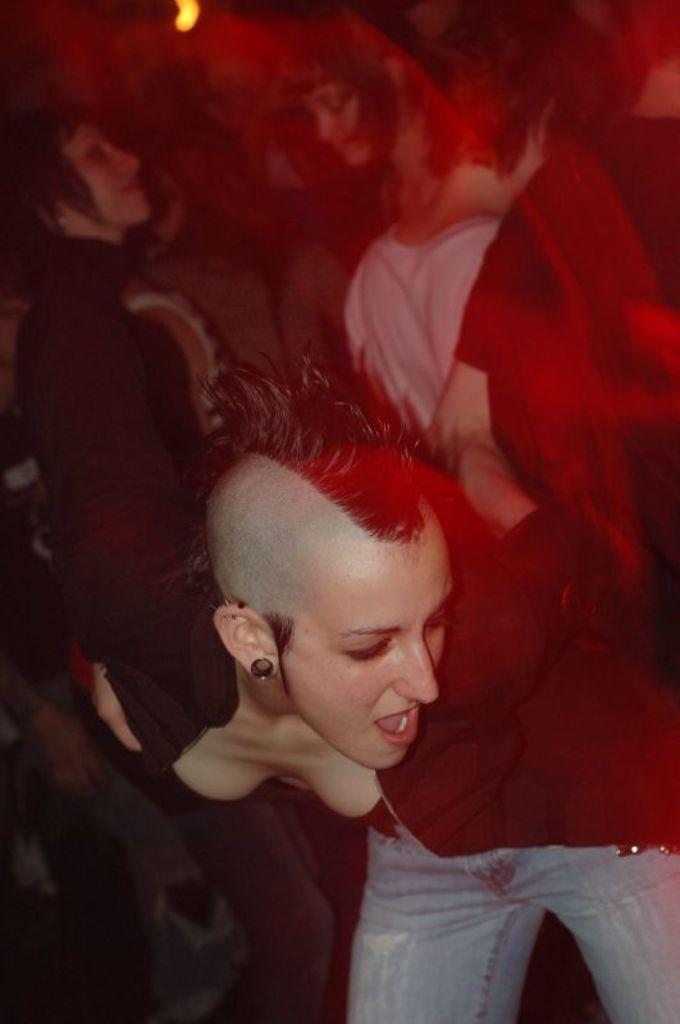How many persons can be seen in the image? There are persons in the image, but the exact number is not specified. What type of light is visible in the image? There is light visible in the image, but the specific source or type of light is not mentioned. What type of system is responsible for maintaining peace in the image? There is no mention of a system or peace in the image, so it is not possible to determine what system might be responsible for maintaining peace. 